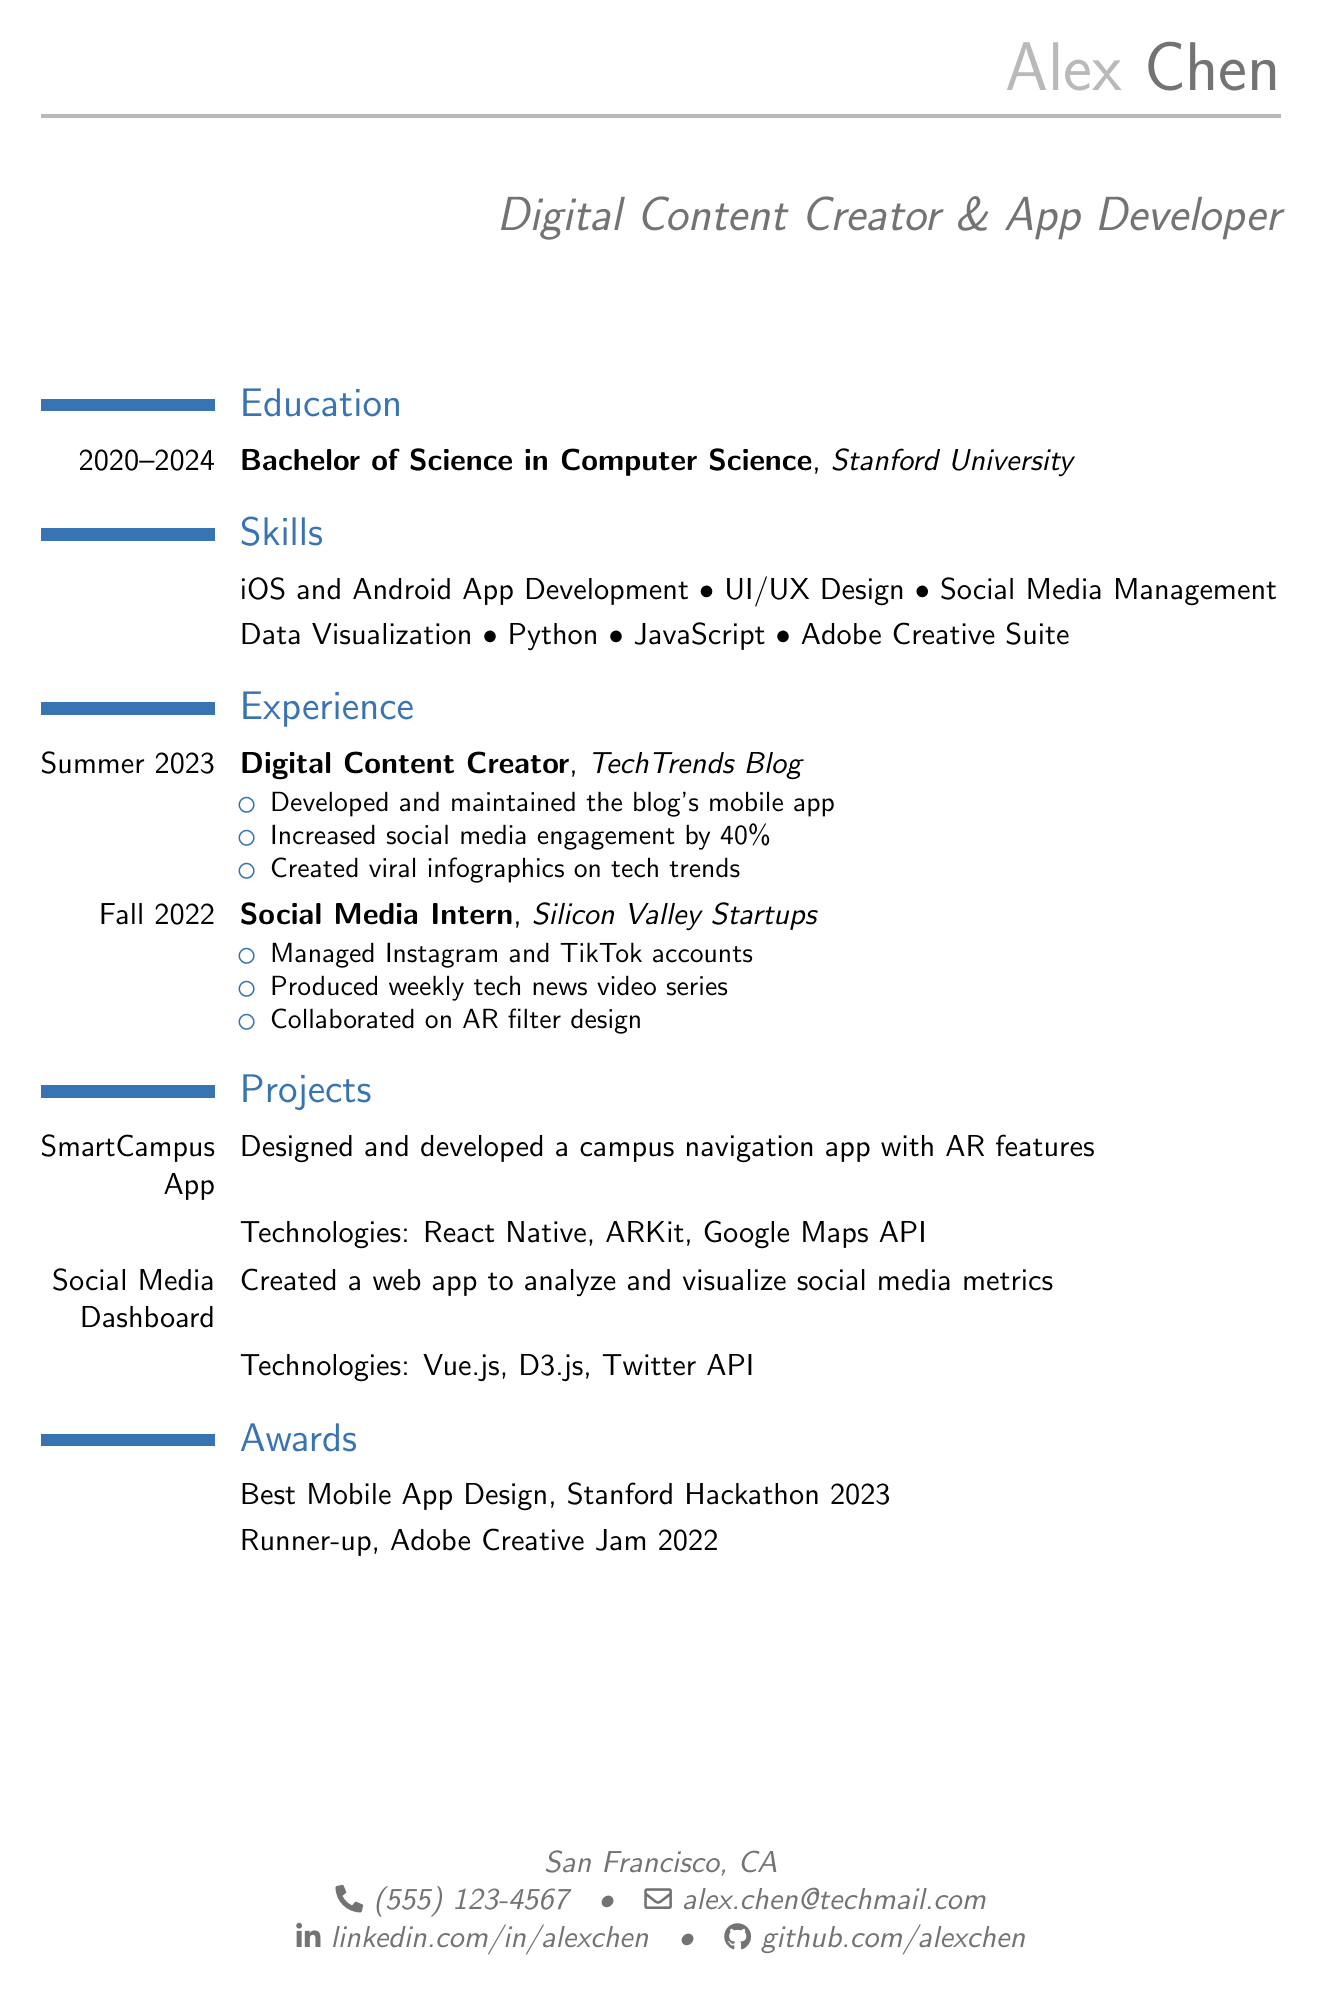what is the name of the person on the resume? The name of the person is stated at the beginning of the document.
Answer: Alex Chen what is the degree obtained by Alex? The degree is mentioned in the education section of the document.
Answer: Bachelor of Science in Computer Science which company did Alex work for as a Digital Content Creator? The company is listed under the experience section of the resume.
Answer: TechTrends Blog what year is Alex expected to graduate? The graduation year is specified in the education section.
Answer: 2024 how many social media profiles are listed in the document? The number of profiles can be counted from the social media section.
Answer: 3 what technology was used to develop the SmartCampus App? This is specified in the projects section of the document.
Answer: React Native what was the increase in social media engagement achieved by Alex? This percentage is mentioned in the achievements of the experience section.
Answer: 40% which award did Alex receive at the Stanford Hackathon? The specific award is noted in the awards section of the document.
Answer: Best Mobile App Design what is one of the skills listed on the resume? Skills are listed under the skills section, and any one of them would answer this question.
Answer: iOS and Android App Development 